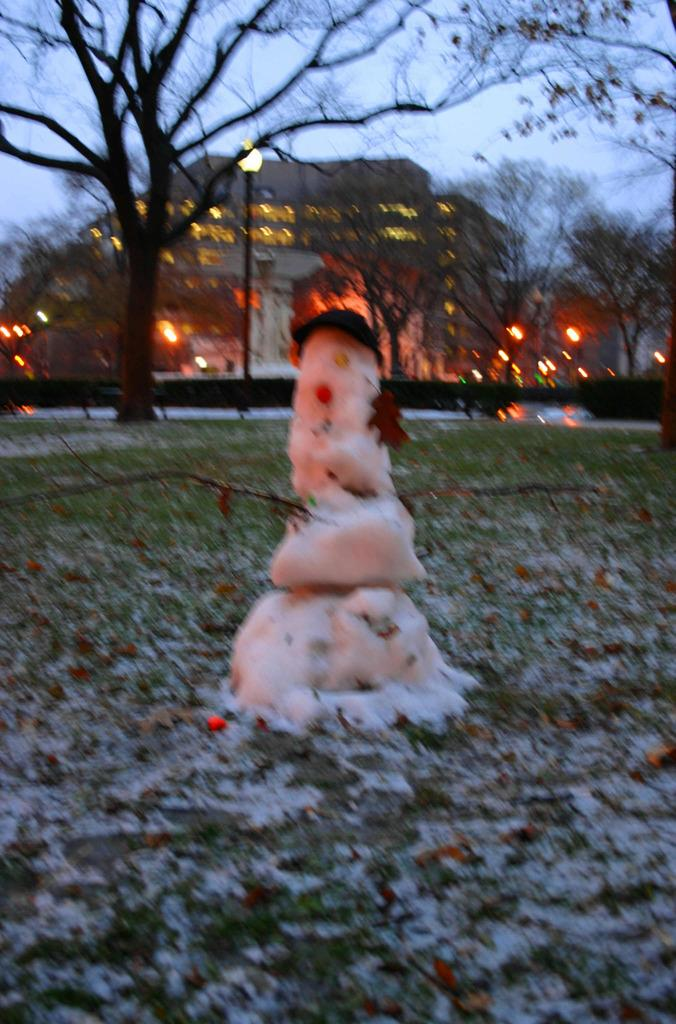What is the main subject of the image? There is a snowman in the image. What type of vegetation is visible in the image? There is grass in the image. What can be seen in the background of the image? There are trees, a building, lights, and the sky visible in the background of the image. What word does the snail spell out on the snowman's carrot nose? There is no snail or carrot nose present in the image, so it is not possible to answer that question. 